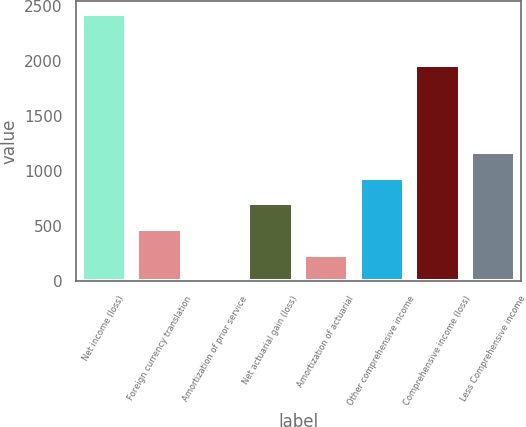<chart> <loc_0><loc_0><loc_500><loc_500><bar_chart><fcel>Net income (loss)<fcel>Foreign currency translation<fcel>Amortization of prior service<fcel>Net actuarial gain (loss)<fcel>Amortization of actuarial<fcel>Other comprehensive income<fcel>Comprehensive income (loss)<fcel>Less Comprehensive income<nl><fcel>2423.8<fcel>471.8<fcel>5<fcel>705.2<fcel>238.4<fcel>938.6<fcel>1957<fcel>1172<nl></chart> 